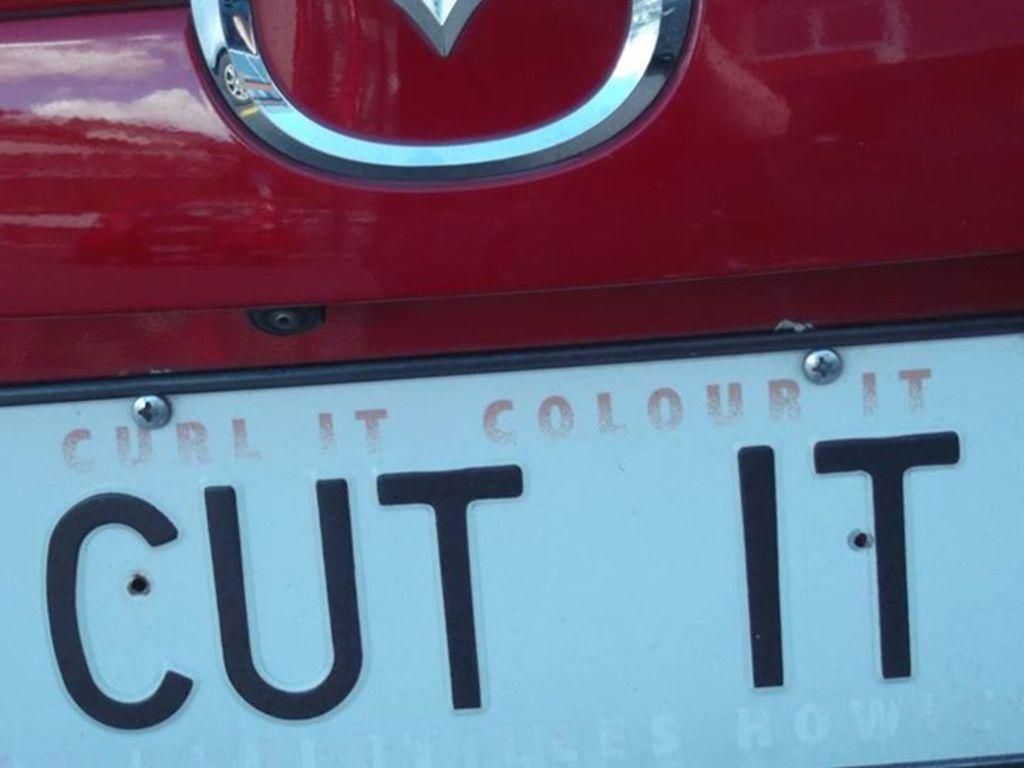<image>
Render a clear and concise summary of the photo. The back of a red vehicle with the license plate reading cut it. 